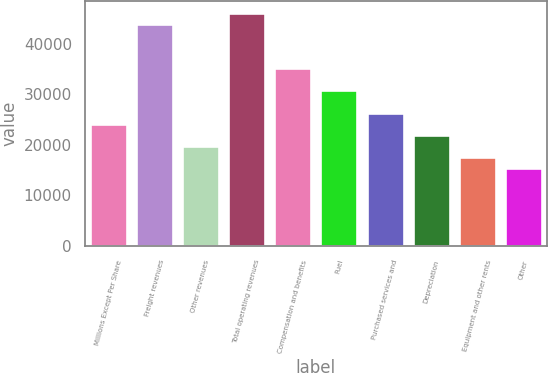Convert chart to OTSL. <chart><loc_0><loc_0><loc_500><loc_500><bar_chart><fcel>Millions Except Per Share<fcel>Freight revenues<fcel>Other revenues<fcel>Total operating revenues<fcel>Compensation and benefits<fcel>Fuel<fcel>Purchased services and<fcel>Depreciation<fcel>Equipment and other rents<fcel>Other<nl><fcel>24159<fcel>43923<fcel>19767<fcel>46119<fcel>35139<fcel>30747<fcel>26355<fcel>21963<fcel>17571<fcel>15375<nl></chart> 